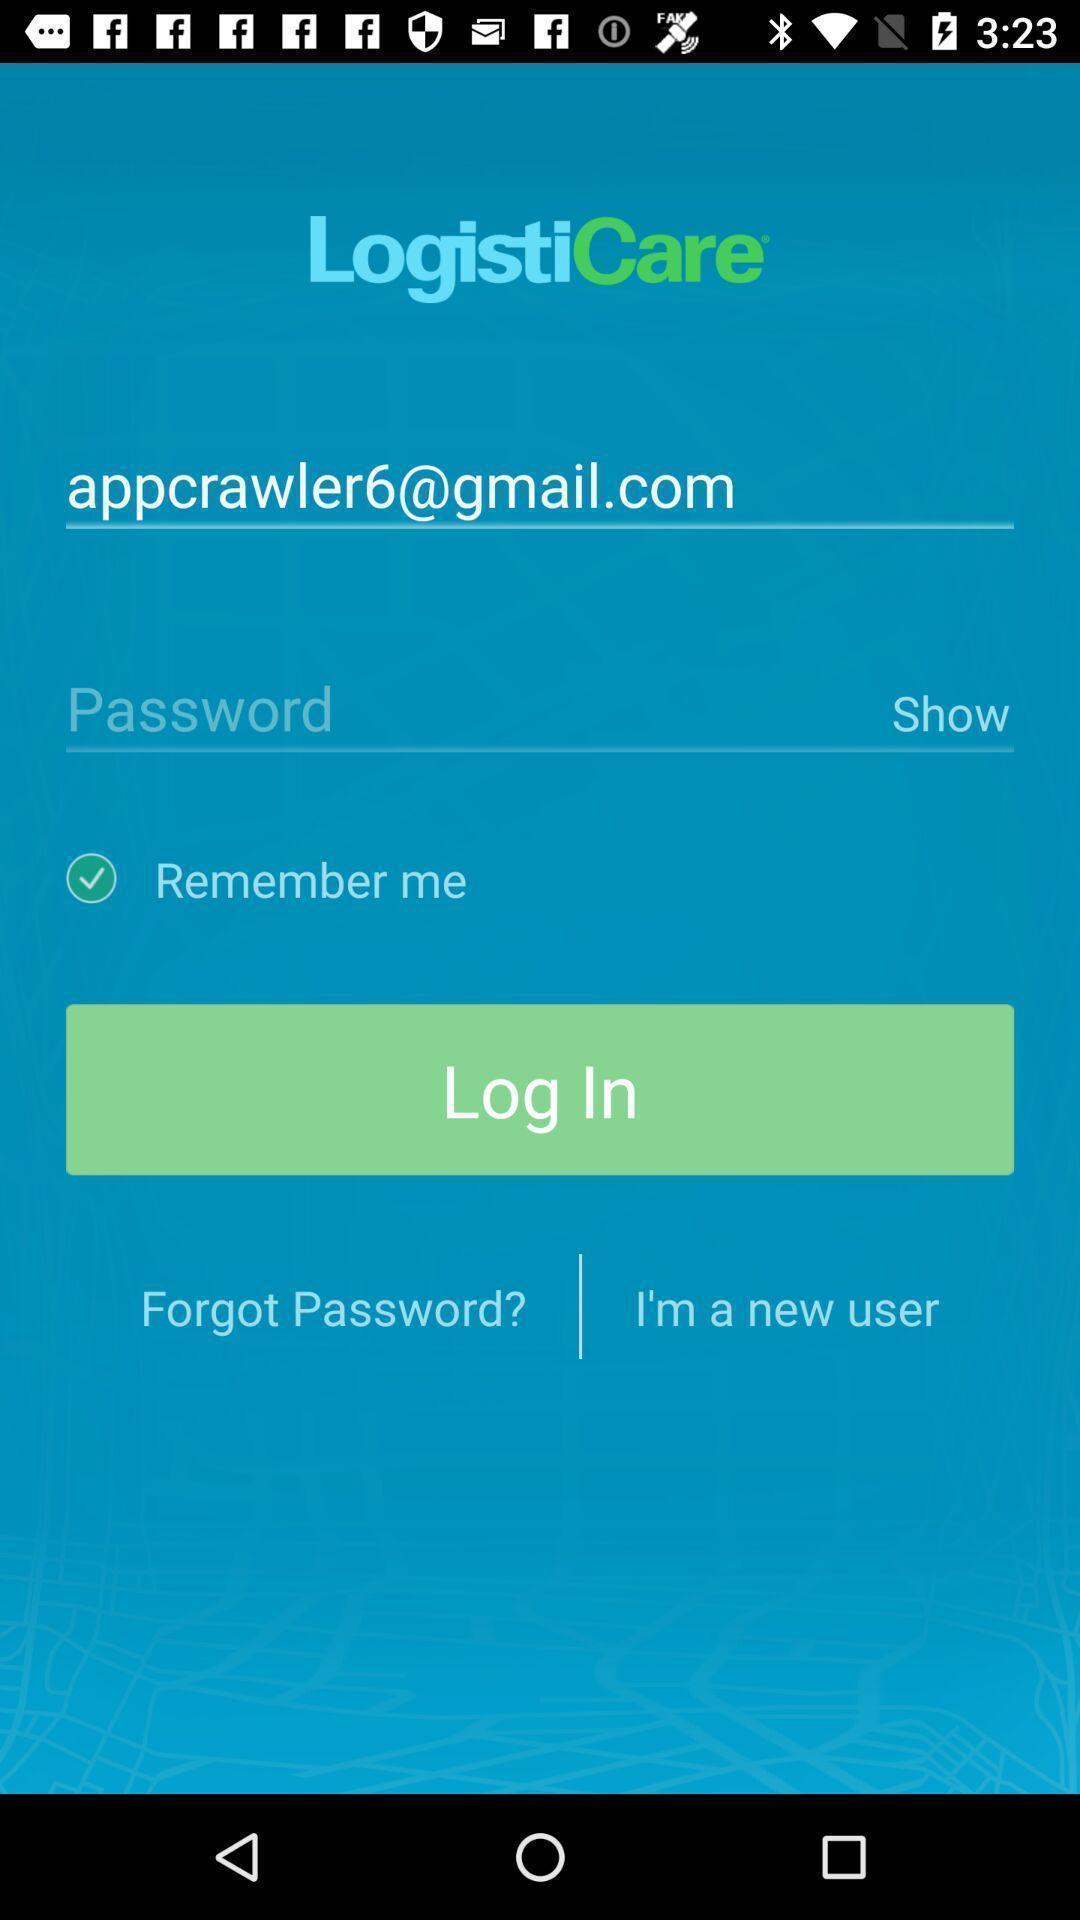What is the overall content of this screenshot? Screen displaying login page contents of a trip management application. 